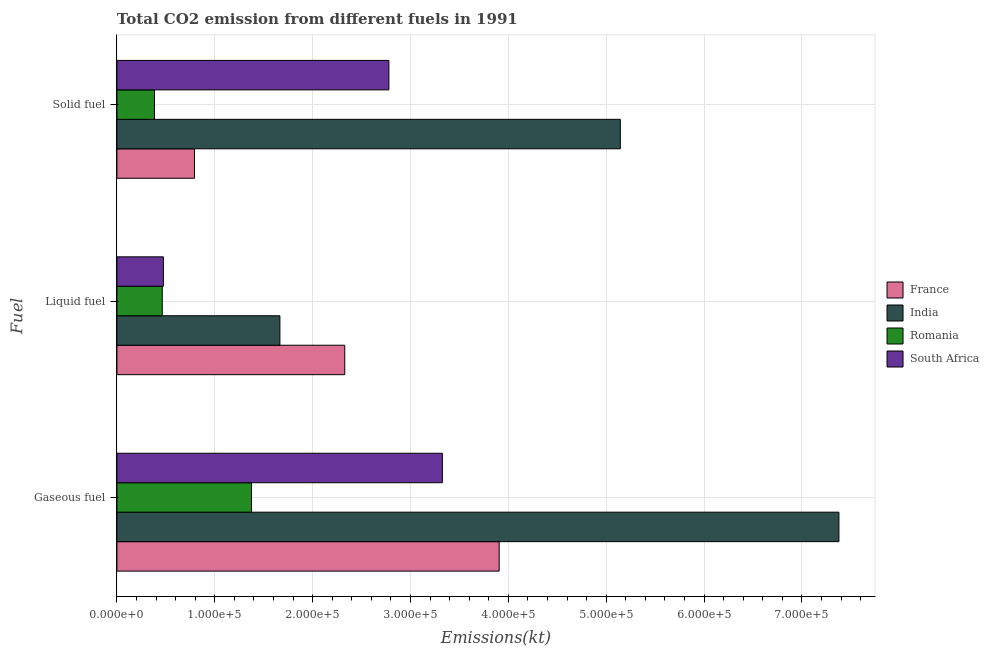How many different coloured bars are there?
Your answer should be compact. 4. Are the number of bars per tick equal to the number of legend labels?
Offer a terse response. Yes. What is the label of the 3rd group of bars from the top?
Make the answer very short. Gaseous fuel. What is the amount of co2 emissions from gaseous fuel in South Africa?
Provide a succinct answer. 3.33e+05. Across all countries, what is the maximum amount of co2 emissions from solid fuel?
Offer a very short reply. 5.14e+05. Across all countries, what is the minimum amount of co2 emissions from gaseous fuel?
Provide a succinct answer. 1.38e+05. In which country was the amount of co2 emissions from gaseous fuel minimum?
Provide a short and direct response. Romania. What is the total amount of co2 emissions from solid fuel in the graph?
Provide a succinct answer. 9.10e+05. What is the difference between the amount of co2 emissions from liquid fuel in India and that in South Africa?
Your answer should be compact. 1.19e+05. What is the difference between the amount of co2 emissions from liquid fuel in Romania and the amount of co2 emissions from solid fuel in India?
Ensure brevity in your answer.  -4.68e+05. What is the average amount of co2 emissions from gaseous fuel per country?
Offer a very short reply. 4.00e+05. What is the difference between the amount of co2 emissions from liquid fuel and amount of co2 emissions from solid fuel in India?
Keep it short and to the point. -3.48e+05. In how many countries, is the amount of co2 emissions from liquid fuel greater than 240000 kt?
Make the answer very short. 0. What is the ratio of the amount of co2 emissions from liquid fuel in France to that in India?
Your answer should be compact. 1.4. Is the amount of co2 emissions from liquid fuel in France less than that in South Africa?
Keep it short and to the point. No. Is the difference between the amount of co2 emissions from solid fuel in France and South Africa greater than the difference between the amount of co2 emissions from gaseous fuel in France and South Africa?
Offer a terse response. No. What is the difference between the highest and the second highest amount of co2 emissions from gaseous fuel?
Your answer should be compact. 3.47e+05. What is the difference between the highest and the lowest amount of co2 emissions from liquid fuel?
Keep it short and to the point. 1.87e+05. What does the 4th bar from the bottom in Liquid fuel represents?
Offer a very short reply. South Africa. Is it the case that in every country, the sum of the amount of co2 emissions from gaseous fuel and amount of co2 emissions from liquid fuel is greater than the amount of co2 emissions from solid fuel?
Your answer should be very brief. Yes. How many bars are there?
Make the answer very short. 12. How many countries are there in the graph?
Offer a terse response. 4. What is the difference between two consecutive major ticks on the X-axis?
Provide a short and direct response. 1.00e+05. Are the values on the major ticks of X-axis written in scientific E-notation?
Your answer should be very brief. Yes. Where does the legend appear in the graph?
Ensure brevity in your answer.  Center right. How many legend labels are there?
Keep it short and to the point. 4. What is the title of the graph?
Ensure brevity in your answer.  Total CO2 emission from different fuels in 1991. What is the label or title of the X-axis?
Give a very brief answer. Emissions(kt). What is the label or title of the Y-axis?
Your response must be concise. Fuel. What is the Emissions(kt) in France in Gaseous fuel?
Offer a very short reply. 3.91e+05. What is the Emissions(kt) in India in Gaseous fuel?
Your answer should be compact. 7.38e+05. What is the Emissions(kt) of Romania in Gaseous fuel?
Your response must be concise. 1.38e+05. What is the Emissions(kt) in South Africa in Gaseous fuel?
Provide a succinct answer. 3.33e+05. What is the Emissions(kt) in France in Liquid fuel?
Provide a short and direct response. 2.33e+05. What is the Emissions(kt) of India in Liquid fuel?
Your answer should be compact. 1.67e+05. What is the Emissions(kt) of Romania in Liquid fuel?
Provide a succinct answer. 4.63e+04. What is the Emissions(kt) of South Africa in Liquid fuel?
Keep it short and to the point. 4.75e+04. What is the Emissions(kt) of France in Solid fuel?
Give a very brief answer. 7.92e+04. What is the Emissions(kt) of India in Solid fuel?
Ensure brevity in your answer.  5.14e+05. What is the Emissions(kt) of Romania in Solid fuel?
Keep it short and to the point. 3.84e+04. What is the Emissions(kt) of South Africa in Solid fuel?
Provide a succinct answer. 2.78e+05. Across all Fuel, what is the maximum Emissions(kt) of France?
Provide a short and direct response. 3.91e+05. Across all Fuel, what is the maximum Emissions(kt) of India?
Your answer should be compact. 7.38e+05. Across all Fuel, what is the maximum Emissions(kt) of Romania?
Provide a succinct answer. 1.38e+05. Across all Fuel, what is the maximum Emissions(kt) of South Africa?
Provide a short and direct response. 3.33e+05. Across all Fuel, what is the minimum Emissions(kt) in France?
Offer a very short reply. 7.92e+04. Across all Fuel, what is the minimum Emissions(kt) of India?
Give a very brief answer. 1.67e+05. Across all Fuel, what is the minimum Emissions(kt) in Romania?
Offer a terse response. 3.84e+04. Across all Fuel, what is the minimum Emissions(kt) in South Africa?
Make the answer very short. 4.75e+04. What is the total Emissions(kt) in France in the graph?
Your response must be concise. 7.03e+05. What is the total Emissions(kt) of India in the graph?
Make the answer very short. 1.42e+06. What is the total Emissions(kt) of Romania in the graph?
Keep it short and to the point. 2.22e+05. What is the total Emissions(kt) in South Africa in the graph?
Your answer should be very brief. 6.58e+05. What is the difference between the Emissions(kt) of France in Gaseous fuel and that in Liquid fuel?
Provide a short and direct response. 1.58e+05. What is the difference between the Emissions(kt) in India in Gaseous fuel and that in Liquid fuel?
Offer a terse response. 5.71e+05. What is the difference between the Emissions(kt) of Romania in Gaseous fuel and that in Liquid fuel?
Your response must be concise. 9.12e+04. What is the difference between the Emissions(kt) in South Africa in Gaseous fuel and that in Liquid fuel?
Your answer should be compact. 2.85e+05. What is the difference between the Emissions(kt) of France in Gaseous fuel and that in Solid fuel?
Make the answer very short. 3.11e+05. What is the difference between the Emissions(kt) in India in Gaseous fuel and that in Solid fuel?
Give a very brief answer. 2.23e+05. What is the difference between the Emissions(kt) of Romania in Gaseous fuel and that in Solid fuel?
Give a very brief answer. 9.91e+04. What is the difference between the Emissions(kt) in South Africa in Gaseous fuel and that in Solid fuel?
Offer a terse response. 5.47e+04. What is the difference between the Emissions(kt) of France in Liquid fuel and that in Solid fuel?
Your answer should be very brief. 1.54e+05. What is the difference between the Emissions(kt) of India in Liquid fuel and that in Solid fuel?
Keep it short and to the point. -3.48e+05. What is the difference between the Emissions(kt) of Romania in Liquid fuel and that in Solid fuel?
Provide a short and direct response. 7946.39. What is the difference between the Emissions(kt) of South Africa in Liquid fuel and that in Solid fuel?
Ensure brevity in your answer.  -2.30e+05. What is the difference between the Emissions(kt) in France in Gaseous fuel and the Emissions(kt) in India in Liquid fuel?
Give a very brief answer. 2.24e+05. What is the difference between the Emissions(kt) of France in Gaseous fuel and the Emissions(kt) of Romania in Liquid fuel?
Offer a terse response. 3.44e+05. What is the difference between the Emissions(kt) of France in Gaseous fuel and the Emissions(kt) of South Africa in Liquid fuel?
Ensure brevity in your answer.  3.43e+05. What is the difference between the Emissions(kt) in India in Gaseous fuel and the Emissions(kt) in Romania in Liquid fuel?
Your answer should be compact. 6.92e+05. What is the difference between the Emissions(kt) of India in Gaseous fuel and the Emissions(kt) of South Africa in Liquid fuel?
Your answer should be very brief. 6.90e+05. What is the difference between the Emissions(kt) in Romania in Gaseous fuel and the Emissions(kt) in South Africa in Liquid fuel?
Make the answer very short. 9.01e+04. What is the difference between the Emissions(kt) of France in Gaseous fuel and the Emissions(kt) of India in Solid fuel?
Provide a short and direct response. -1.24e+05. What is the difference between the Emissions(kt) of France in Gaseous fuel and the Emissions(kt) of Romania in Solid fuel?
Your answer should be very brief. 3.52e+05. What is the difference between the Emissions(kt) of France in Gaseous fuel and the Emissions(kt) of South Africa in Solid fuel?
Provide a succinct answer. 1.13e+05. What is the difference between the Emissions(kt) in India in Gaseous fuel and the Emissions(kt) in Romania in Solid fuel?
Your answer should be very brief. 6.99e+05. What is the difference between the Emissions(kt) in India in Gaseous fuel and the Emissions(kt) in South Africa in Solid fuel?
Make the answer very short. 4.60e+05. What is the difference between the Emissions(kt) in Romania in Gaseous fuel and the Emissions(kt) in South Africa in Solid fuel?
Offer a very short reply. -1.40e+05. What is the difference between the Emissions(kt) in France in Liquid fuel and the Emissions(kt) in India in Solid fuel?
Keep it short and to the point. -2.82e+05. What is the difference between the Emissions(kt) in France in Liquid fuel and the Emissions(kt) in Romania in Solid fuel?
Ensure brevity in your answer.  1.94e+05. What is the difference between the Emissions(kt) in France in Liquid fuel and the Emissions(kt) in South Africa in Solid fuel?
Provide a short and direct response. -4.51e+04. What is the difference between the Emissions(kt) in India in Liquid fuel and the Emissions(kt) in Romania in Solid fuel?
Your answer should be compact. 1.28e+05. What is the difference between the Emissions(kt) in India in Liquid fuel and the Emissions(kt) in South Africa in Solid fuel?
Ensure brevity in your answer.  -1.11e+05. What is the difference between the Emissions(kt) in Romania in Liquid fuel and the Emissions(kt) in South Africa in Solid fuel?
Ensure brevity in your answer.  -2.32e+05. What is the average Emissions(kt) in France per Fuel?
Your response must be concise. 2.34e+05. What is the average Emissions(kt) of India per Fuel?
Your answer should be compact. 4.73e+05. What is the average Emissions(kt) of Romania per Fuel?
Provide a short and direct response. 7.41e+04. What is the average Emissions(kt) in South Africa per Fuel?
Your answer should be compact. 2.19e+05. What is the difference between the Emissions(kt) in France and Emissions(kt) in India in Gaseous fuel?
Provide a succinct answer. -3.47e+05. What is the difference between the Emissions(kt) of France and Emissions(kt) of Romania in Gaseous fuel?
Offer a very short reply. 2.53e+05. What is the difference between the Emissions(kt) of France and Emissions(kt) of South Africa in Gaseous fuel?
Your answer should be very brief. 5.80e+04. What is the difference between the Emissions(kt) of India and Emissions(kt) of Romania in Gaseous fuel?
Keep it short and to the point. 6.00e+05. What is the difference between the Emissions(kt) in India and Emissions(kt) in South Africa in Gaseous fuel?
Give a very brief answer. 4.05e+05. What is the difference between the Emissions(kt) in Romania and Emissions(kt) in South Africa in Gaseous fuel?
Provide a succinct answer. -1.95e+05. What is the difference between the Emissions(kt) in France and Emissions(kt) in India in Liquid fuel?
Provide a succinct answer. 6.63e+04. What is the difference between the Emissions(kt) of France and Emissions(kt) of Romania in Liquid fuel?
Keep it short and to the point. 1.87e+05. What is the difference between the Emissions(kt) of France and Emissions(kt) of South Africa in Liquid fuel?
Give a very brief answer. 1.85e+05. What is the difference between the Emissions(kt) of India and Emissions(kt) of Romania in Liquid fuel?
Your response must be concise. 1.20e+05. What is the difference between the Emissions(kt) in India and Emissions(kt) in South Africa in Liquid fuel?
Provide a short and direct response. 1.19e+05. What is the difference between the Emissions(kt) in Romania and Emissions(kt) in South Africa in Liquid fuel?
Ensure brevity in your answer.  -1147.77. What is the difference between the Emissions(kt) of France and Emissions(kt) of India in Solid fuel?
Provide a short and direct response. -4.35e+05. What is the difference between the Emissions(kt) in France and Emissions(kt) in Romania in Solid fuel?
Offer a very short reply. 4.09e+04. What is the difference between the Emissions(kt) in France and Emissions(kt) in South Africa in Solid fuel?
Give a very brief answer. -1.99e+05. What is the difference between the Emissions(kt) in India and Emissions(kt) in Romania in Solid fuel?
Offer a terse response. 4.76e+05. What is the difference between the Emissions(kt) of India and Emissions(kt) of South Africa in Solid fuel?
Provide a succinct answer. 2.36e+05. What is the difference between the Emissions(kt) in Romania and Emissions(kt) in South Africa in Solid fuel?
Your answer should be very brief. -2.40e+05. What is the ratio of the Emissions(kt) in France in Gaseous fuel to that in Liquid fuel?
Your answer should be very brief. 1.68. What is the ratio of the Emissions(kt) in India in Gaseous fuel to that in Liquid fuel?
Ensure brevity in your answer.  4.43. What is the ratio of the Emissions(kt) in Romania in Gaseous fuel to that in Liquid fuel?
Provide a succinct answer. 2.97. What is the ratio of the Emissions(kt) of South Africa in Gaseous fuel to that in Liquid fuel?
Your response must be concise. 7.01. What is the ratio of the Emissions(kt) of France in Gaseous fuel to that in Solid fuel?
Keep it short and to the point. 4.93. What is the ratio of the Emissions(kt) in India in Gaseous fuel to that in Solid fuel?
Give a very brief answer. 1.43. What is the ratio of the Emissions(kt) of Romania in Gaseous fuel to that in Solid fuel?
Offer a terse response. 3.58. What is the ratio of the Emissions(kt) in South Africa in Gaseous fuel to that in Solid fuel?
Your response must be concise. 1.2. What is the ratio of the Emissions(kt) of France in Liquid fuel to that in Solid fuel?
Your answer should be compact. 2.94. What is the ratio of the Emissions(kt) of India in Liquid fuel to that in Solid fuel?
Your answer should be very brief. 0.32. What is the ratio of the Emissions(kt) of Romania in Liquid fuel to that in Solid fuel?
Your response must be concise. 1.21. What is the ratio of the Emissions(kt) in South Africa in Liquid fuel to that in Solid fuel?
Ensure brevity in your answer.  0.17. What is the difference between the highest and the second highest Emissions(kt) in France?
Provide a succinct answer. 1.58e+05. What is the difference between the highest and the second highest Emissions(kt) in India?
Provide a short and direct response. 2.23e+05. What is the difference between the highest and the second highest Emissions(kt) in Romania?
Offer a very short reply. 9.12e+04. What is the difference between the highest and the second highest Emissions(kt) in South Africa?
Keep it short and to the point. 5.47e+04. What is the difference between the highest and the lowest Emissions(kt) in France?
Provide a succinct answer. 3.11e+05. What is the difference between the highest and the lowest Emissions(kt) in India?
Your answer should be compact. 5.71e+05. What is the difference between the highest and the lowest Emissions(kt) in Romania?
Give a very brief answer. 9.91e+04. What is the difference between the highest and the lowest Emissions(kt) of South Africa?
Keep it short and to the point. 2.85e+05. 